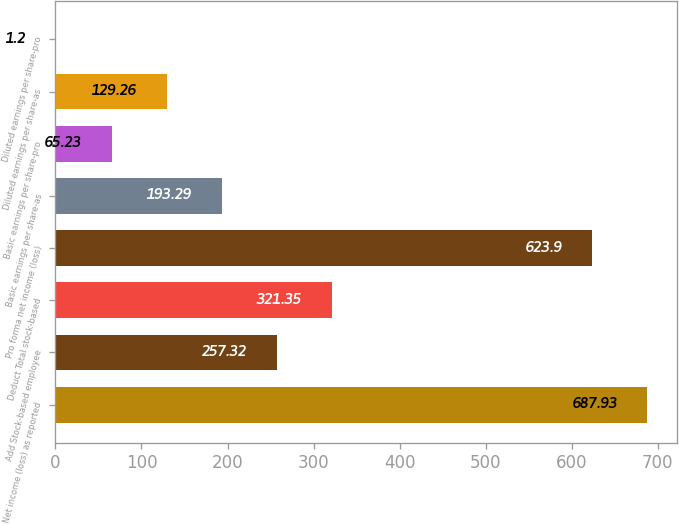Convert chart to OTSL. <chart><loc_0><loc_0><loc_500><loc_500><bar_chart><fcel>Net income (loss) as reported<fcel>Add Stock-based employee<fcel>Deduct Total stock-based<fcel>Pro forma net income (loss)<fcel>Basic earnings per share-as<fcel>Basic earnings per share-pro<fcel>Diluted earnings per share-as<fcel>Diluted earnings per share-pro<nl><fcel>687.93<fcel>257.32<fcel>321.35<fcel>623.9<fcel>193.29<fcel>65.23<fcel>129.26<fcel>1.2<nl></chart> 